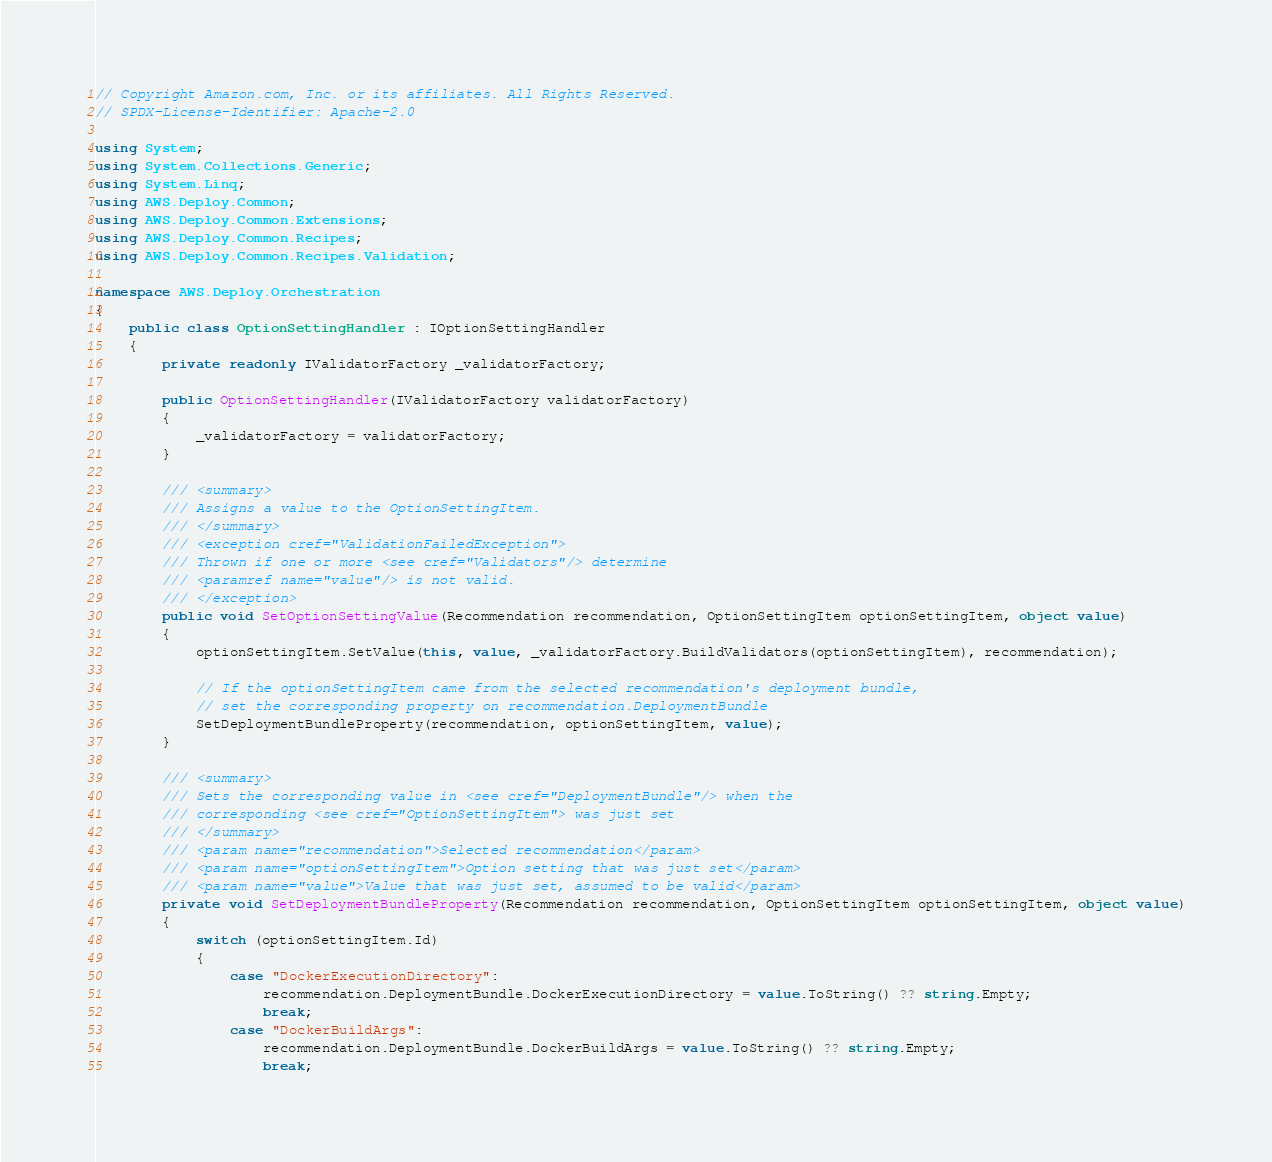Convert code to text. <code><loc_0><loc_0><loc_500><loc_500><_C#_>// Copyright Amazon.com, Inc. or its affiliates. All Rights Reserved.
// SPDX-License-Identifier: Apache-2.0

using System;
using System.Collections.Generic;
using System.Linq;
using AWS.Deploy.Common;
using AWS.Deploy.Common.Extensions;
using AWS.Deploy.Common.Recipes;
using AWS.Deploy.Common.Recipes.Validation;

namespace AWS.Deploy.Orchestration
{
    public class OptionSettingHandler : IOptionSettingHandler
    {
        private readonly IValidatorFactory _validatorFactory;

        public OptionSettingHandler(IValidatorFactory validatorFactory)
        {
            _validatorFactory = validatorFactory;
        }

        /// <summary>
        /// Assigns a value to the OptionSettingItem.
        /// </summary>
        /// <exception cref="ValidationFailedException">
        /// Thrown if one or more <see cref="Validators"/> determine
        /// <paramref name="value"/> is not valid.
        /// </exception>
        public void SetOptionSettingValue(Recommendation recommendation, OptionSettingItem optionSettingItem, object value)
        {
            optionSettingItem.SetValue(this, value, _validatorFactory.BuildValidators(optionSettingItem), recommendation);

            // If the optionSettingItem came from the selected recommendation's deployment bundle,
            // set the corresponding property on recommendation.DeploymentBundle
            SetDeploymentBundleProperty(recommendation, optionSettingItem, value);
        }

        /// <summary>
        /// Sets the corresponding value in <see cref="DeploymentBundle"/> when the
        /// corresponding <see cref="OptionSettingItem"> was just set
        /// </summary>
        /// <param name="recommendation">Selected recommendation</param>
        /// <param name="optionSettingItem">Option setting that was just set</param>
        /// <param name="value">Value that was just set, assumed to be valid</param>
        private void SetDeploymentBundleProperty(Recommendation recommendation, OptionSettingItem optionSettingItem, object value)
        {
            switch (optionSettingItem.Id)
            {
                case "DockerExecutionDirectory":
                    recommendation.DeploymentBundle.DockerExecutionDirectory = value.ToString() ?? string.Empty;
                    break;
                case "DockerBuildArgs":
                    recommendation.DeploymentBundle.DockerBuildArgs = value.ToString() ?? string.Empty;
                    break;</code> 